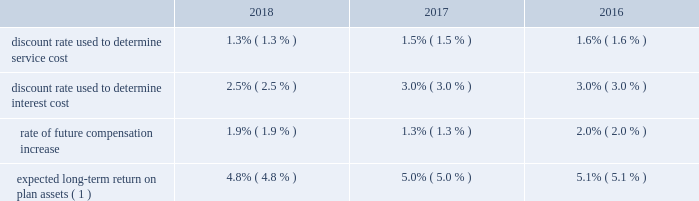Remaining service period of active members expected to receive benefits under the plan or , in the case of closed plans , the expected future lifetime of the employees participating in the plan .
For the years ended december 31 , 2018 and 2017 , the service cost component of net periodic benefit cost was classified in selling , general and administrative expenses , while the other components of net periodic benefit cost were classified in other income , net in our consolidated statements of income .
For the year ended december 31 , 2016 , all components of net periodic benefit expense were included in selling , general , and administrative expenses in our consolidated statements of income .
For the year ending december 31 , 2019 , we expect net periodic benefit costs to increase by approximately $ 2 million due to the fact that we will incur a full year of pension expense related to our stahlgruber business , compared to a partial year in 2018 .
The table below summarizes the weighted-average assumptions used to calculate the net periodic benefit cost in the table above: .
Expected long-term return on plan assets ( 1 ) 4.8% ( 4.8 % ) 5.0% ( 5.0 % ) 5.1% ( 5.1 % ) ( 1 ) our expected long-term return on plan assets is determined based on our asset allocation and estimate of future long- term returns by asset class .
Assumed mortality is also a key assumption in determining benefit obligations and net periodic benefit cost .
In some of our european plans , a price inflation index is also an assumption in determining benefit obligations and net periodic benefit as of december 31 , 2018 , the pre-tax amounts recognized in accumulated other comprehensive income consisted of $ 10 million of net actuarial losses for our defined benefit plans that have not yet been recognized in net periodic benefit cost .
Of this amount , we expect $ 0.2 million to be recognized as a component of net periodic benefit cost during the year ending december 31 , 2019 .
Fair value of plan assets fair value is defined as the amount that would be received for selling an asset or paid to transfer a liability in an orderly transaction between market participants .
The tiers in the fair value hierarchy include : level 1 , defined as observable inputs such as quoted market prices in active markets ; level 2 , defined as inputs other than quoted prices in active markets that are either directly or indirectly observable ; and level 3 , defined as significant unobservable inputs in which little or no market data exists , therefore requiring an entity to develop its own assumptions .
Investments that are valued using net asset value ( "nav" ) ( or its equivalent ) as a practical expedient are excluded from the fair value hierarchy disclosure .
The following is a description of the valuation methodologies used for assets reported at fair value .
The methodologies used at december 31 , 2018 and december 31 , 2017 are the same .
Level 1 investments : cash and cash equivalents are valued based on cost , which approximates fair value .
Mutual funds are valued based on reported market prices on the last trading day of the fiscal year .
Level 3 investments : investments in insurance contracts represent the cash surrender value of the insurance policy .
These are actuarially determined amounts based on projections of future benefit payments , discount rates , and expected long- term rate of return on assets. .
Based on the review of the weighted-average assumptions used to calculate the net periodic benefit cost what was the ratio of the expected long-term return on plan assets ( 1 ) to the discount rate used to determine service cost in 2017? 
Computations: (5.0 / 1.5)
Answer: 3.33333. 